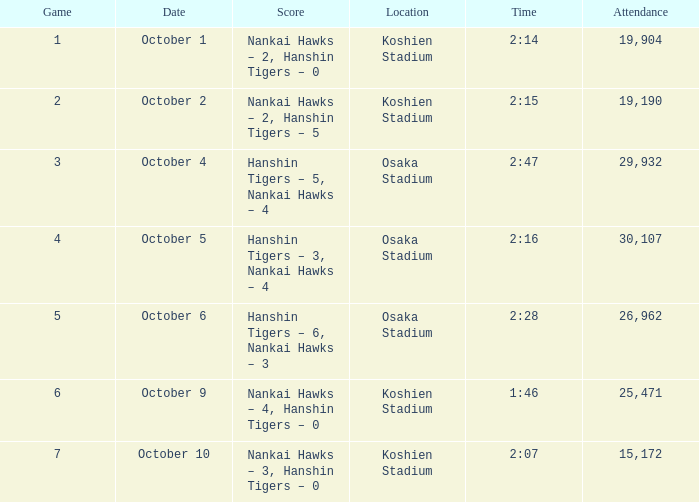Which score holds a duration of 2:28? Hanshin Tigers – 6, Nankai Hawks – 3. 